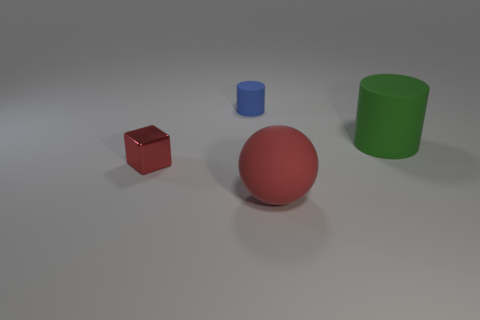Add 3 large rubber objects. How many objects exist? 7 Subtract all spheres. How many objects are left? 3 Add 2 red cylinders. How many red cylinders exist? 2 Subtract 1 red spheres. How many objects are left? 3 Subtract all large objects. Subtract all green metal cylinders. How many objects are left? 2 Add 3 tiny matte cylinders. How many tiny matte cylinders are left? 4 